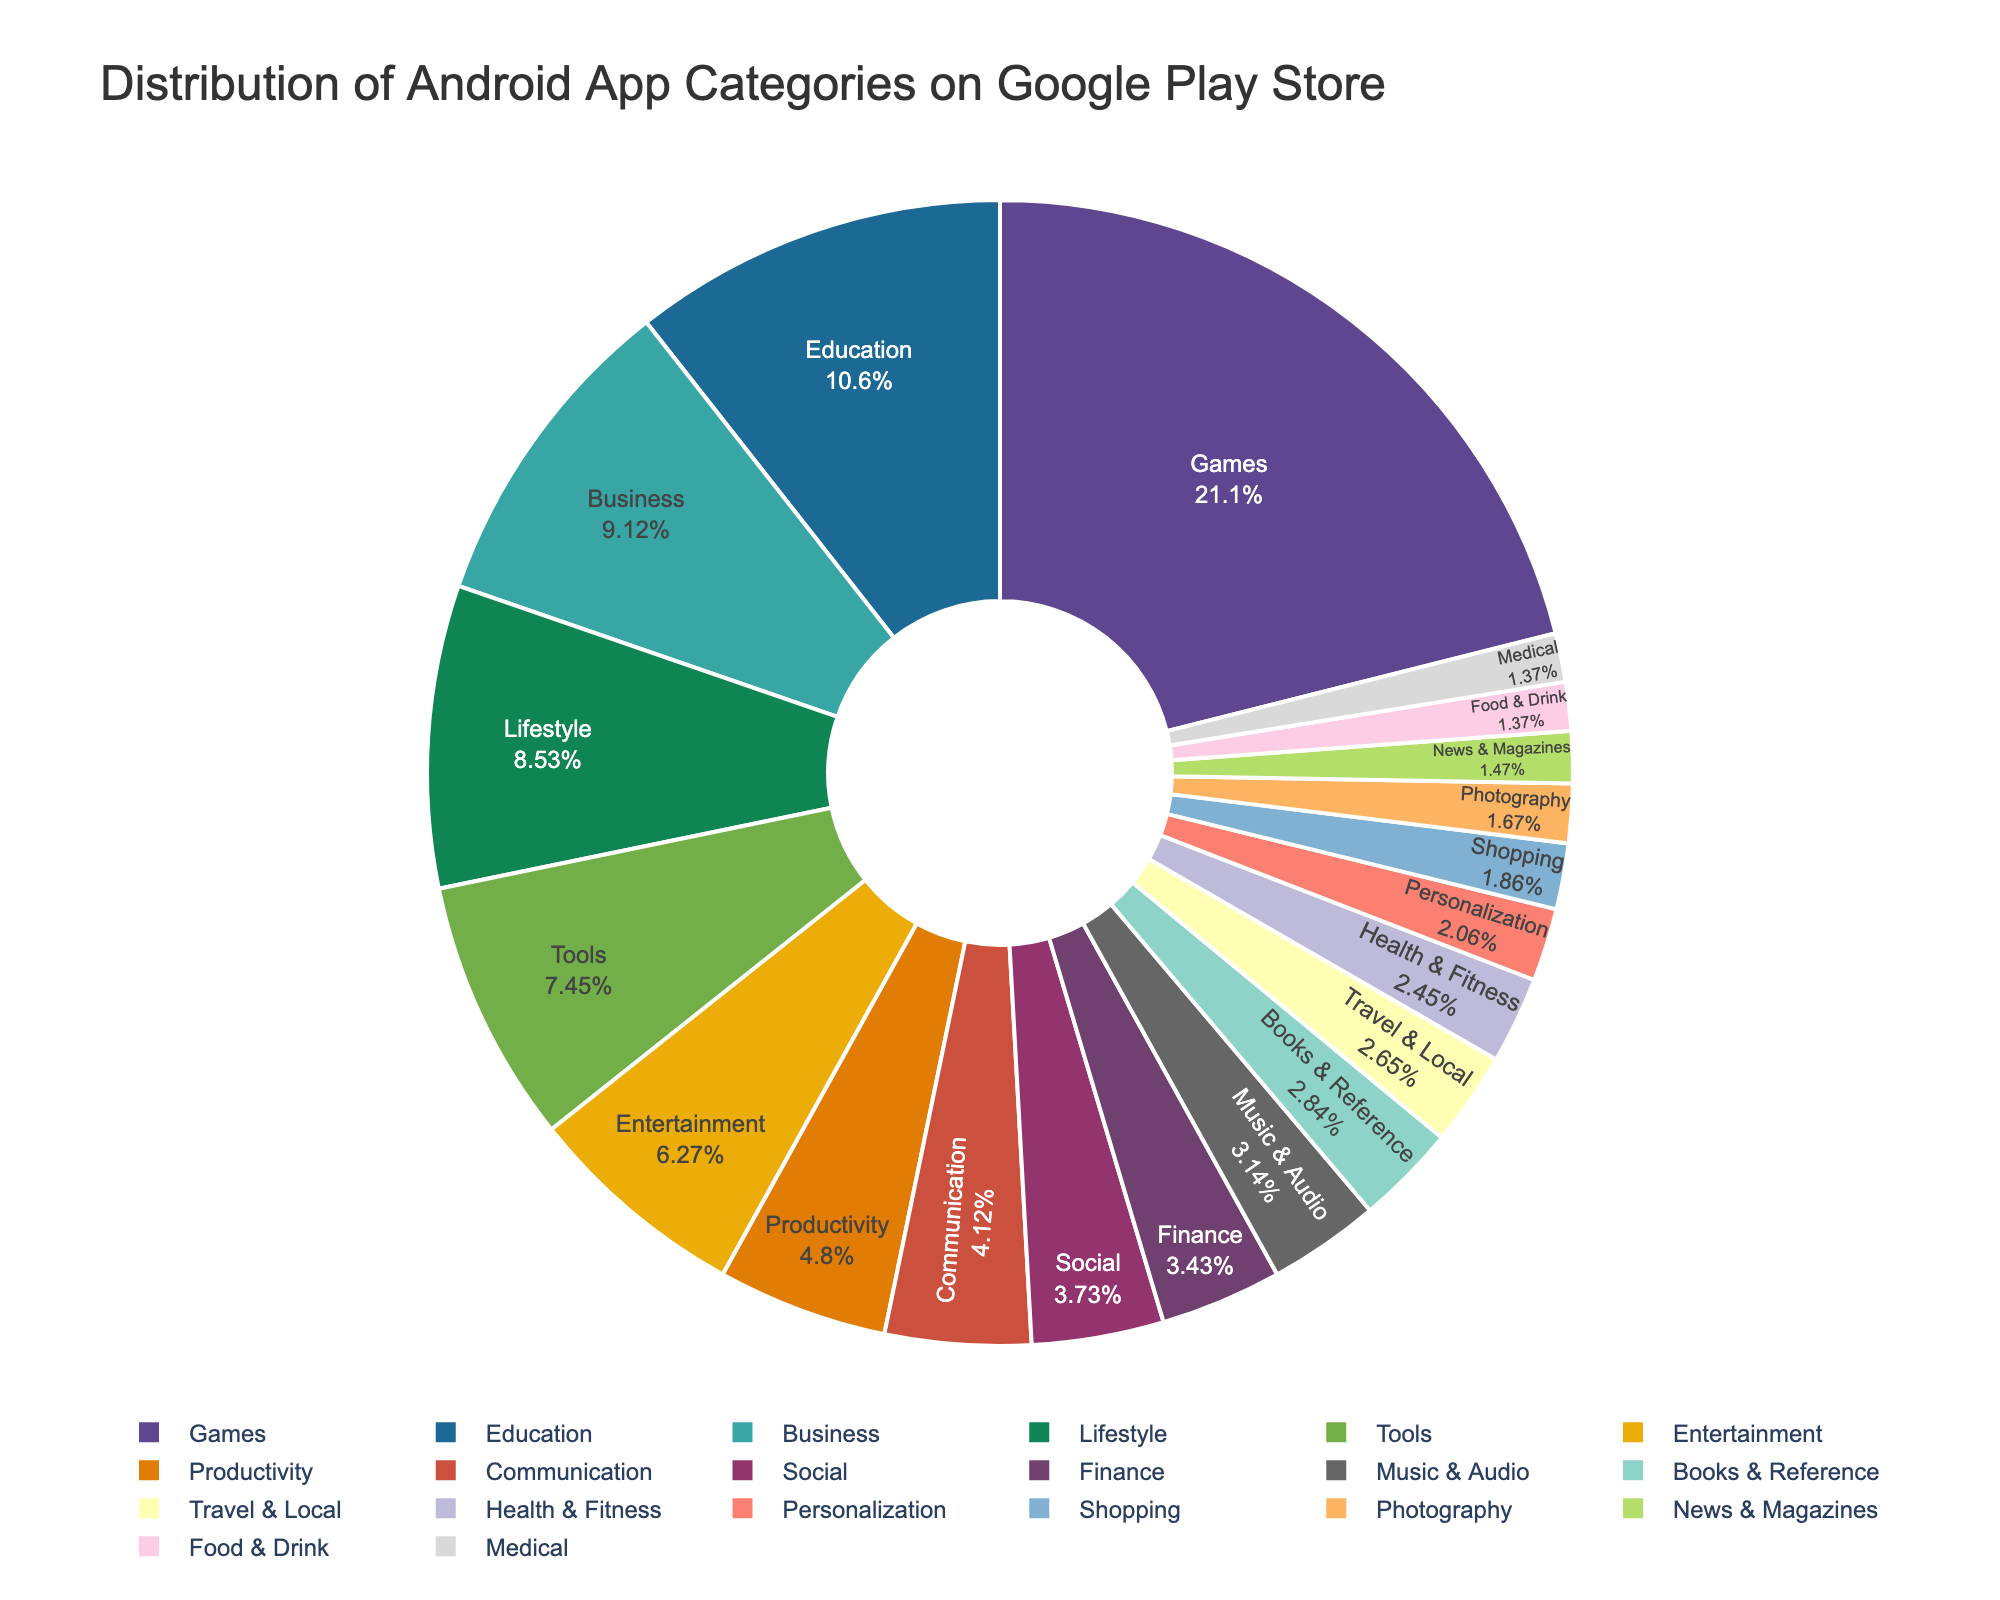What is the most popular category of Android apps on the Google Play Store? To identify the most popular category, look for the category that occupies the largest section of the pie chart, which corresponds to the largest percentage. The "Games" category has the highest percentage at 21.5%.
Answer: Games What is the combined percentage of 'Education' and 'Business' categories? Sum the percentages of the 'Education' and 'Business' categories. 'Education' is 10.8% and 'Business' is 9.3%. 10.8% + 9.3% equals 20.1%.
Answer: 20.1% Which category has a larger share, 'Lifestyle' or 'Tools'? Compare the percentages of 'Lifestyle' and 'Tools' categories. 'Lifestyle' has 8.7% and 'Tools' has 7.6%. Since 8.7% is greater than 7.6%, 'Lifestyle' has a larger share.
Answer: Lifestyle How many categories have a percentage lower than 3%? Identify the categories with percentages below 3% and count them. These categories are 'Books & Reference', 'Travel & Local', 'Health & Fitness', 'Personalization', 'Shopping', 'Photography', 'News & Magazines', 'Food & Drink', and 'Medical'. There are 9 such categories.
Answer: 9 What is the percentage difference between 'Productivity' and 'Entertainment' categories? Subtract the percentage of 'Entertainment' from 'Productivity'. 'Productivity' is 4.9% and 'Entertainment' is 6.4%. The difference is 6.4% - 4.9% which equals 1.5%.
Answer: 1.5% Is the 'Communication' category more popular than the 'Finance' category? Compare the percentages of 'Communication' and 'Finance' categories. 'Communication' has 4.2% while 'Finance' has 3.5%. Since 4.2% is greater than 3.5%, 'Communication' is more popular.
Answer: Yes What is the smallest category shown in the pie chart? To find the smallest category, identify the category with the smallest percentage in the pie chart. 'Medical' and 'Food & Drink' both have the smallest percentage at 1.4%.
Answer: Medical and Food & Drink What is the total percentage of categories with a share greater than 5%? Sum the percentages of categories with a share greater than 5%. These categories are 'Games' (21.5%), 'Education' (10.8%), 'Business' (9.3%), 'Lifestyle' (8.7%), 'Tools' (7.6%), and 'Entertainment' (6.4%). 21.5% + 10.8% + 9.3% + 8.7% + 7.6% + 6.4% equals 64.3%.
Answer: 64.3% Which category is represented by the lightest color in the pie chart? Identify the category represented by the lightest color, which can be done by looking at the visual distinction in the pie chart. (Consider this as a visual interpretation, and it requires actually viewing the chart to answer precisely.)
Answer: (Depends on the actual chart, e.g., 'Medical') What is the average percentage of 'Social', 'Finance', and 'Music & Audio' categories? Calculate the average of the percentages of 'Social' (3.8%), 'Finance' (3.5%), and 'Music & Audio' (3.2%). Sum the percentages and then divide by the number of categories: (3.8% + 3.5% + 3.2%) / 3 equals 3.5%.
Answer: 3.5% 